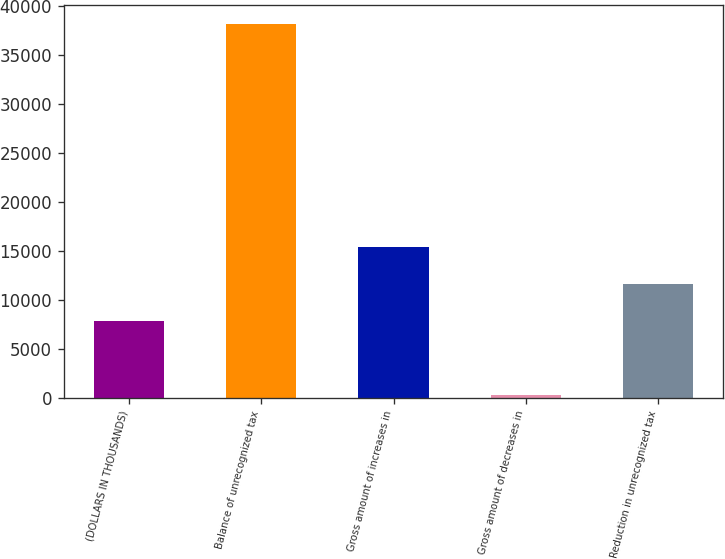Convert chart. <chart><loc_0><loc_0><loc_500><loc_500><bar_chart><fcel>(DOLLARS IN THOUSANDS)<fcel>Balance of unrecognized tax<fcel>Gross amount of increases in<fcel>Gross amount of decreases in<fcel>Reduction in unrecognized tax<nl><fcel>7846.8<fcel>38162<fcel>15425.6<fcel>268<fcel>11636.2<nl></chart> 